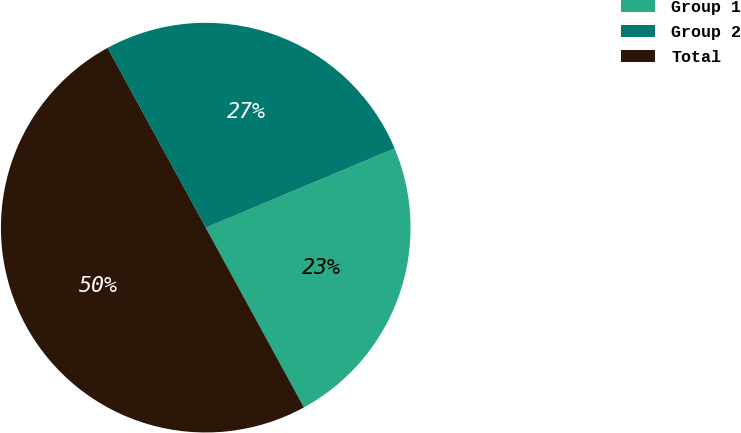Convert chart. <chart><loc_0><loc_0><loc_500><loc_500><pie_chart><fcel>Group 1<fcel>Group 2<fcel>Total<nl><fcel>23.36%<fcel>26.64%<fcel>50.0%<nl></chart> 